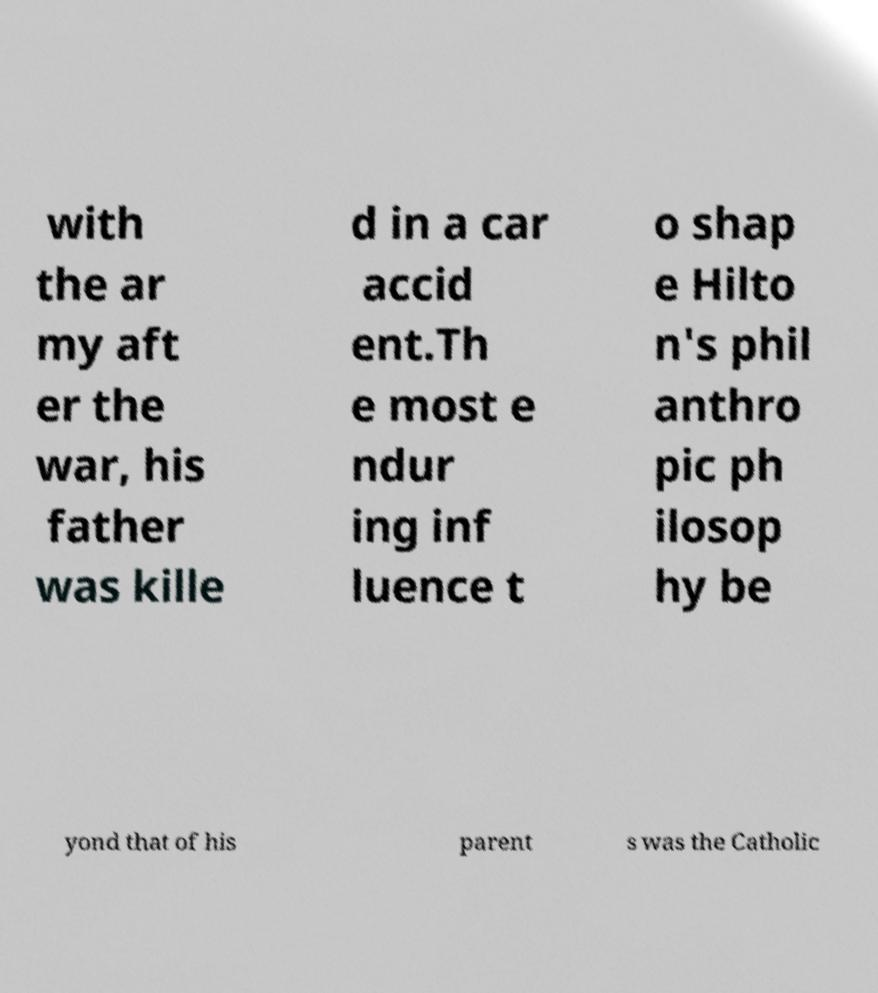Can you read and provide the text displayed in the image?This photo seems to have some interesting text. Can you extract and type it out for me? with the ar my aft er the war, his father was kille d in a car accid ent.Th e most e ndur ing inf luence t o shap e Hilto n's phil anthro pic ph ilosop hy be yond that of his parent s was the Catholic 